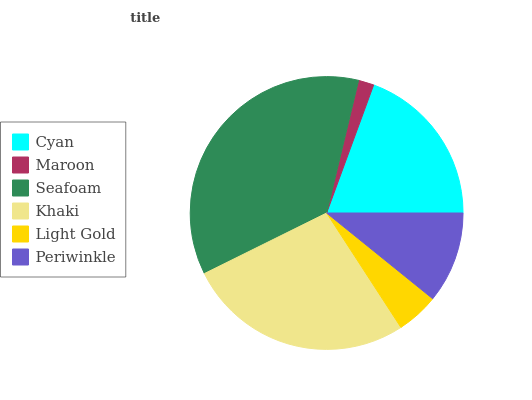Is Maroon the minimum?
Answer yes or no. Yes. Is Seafoam the maximum?
Answer yes or no. Yes. Is Seafoam the minimum?
Answer yes or no. No. Is Maroon the maximum?
Answer yes or no. No. Is Seafoam greater than Maroon?
Answer yes or no. Yes. Is Maroon less than Seafoam?
Answer yes or no. Yes. Is Maroon greater than Seafoam?
Answer yes or no. No. Is Seafoam less than Maroon?
Answer yes or no. No. Is Cyan the high median?
Answer yes or no. Yes. Is Periwinkle the low median?
Answer yes or no. Yes. Is Seafoam the high median?
Answer yes or no. No. Is Maroon the low median?
Answer yes or no. No. 